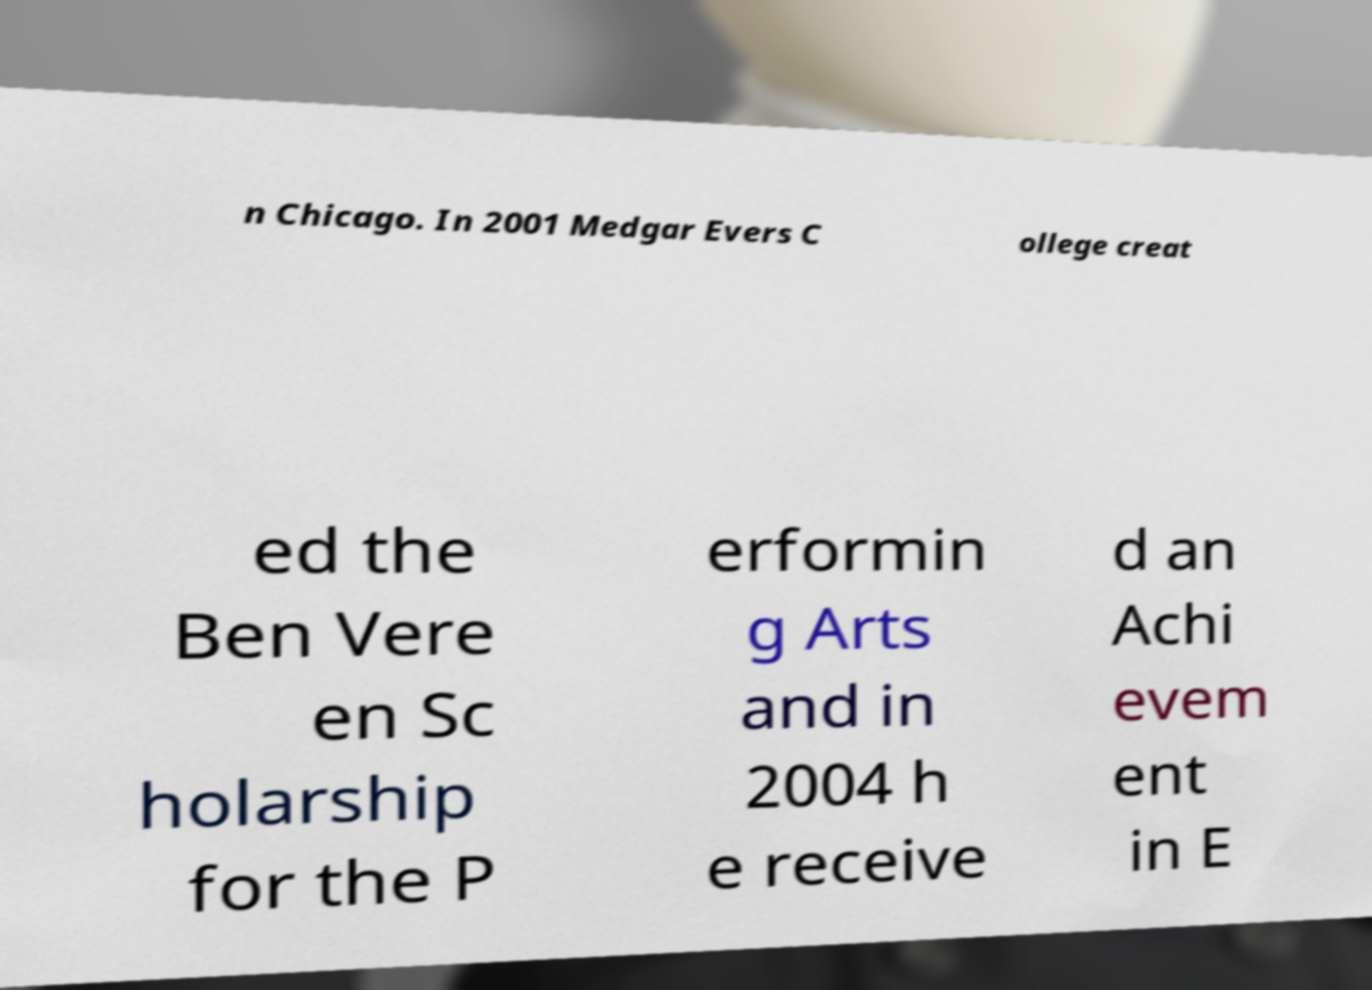There's text embedded in this image that I need extracted. Can you transcribe it verbatim? n Chicago. In 2001 Medgar Evers C ollege creat ed the Ben Vere en Sc holarship for the P erformin g Arts and in 2004 h e receive d an Achi evem ent in E 